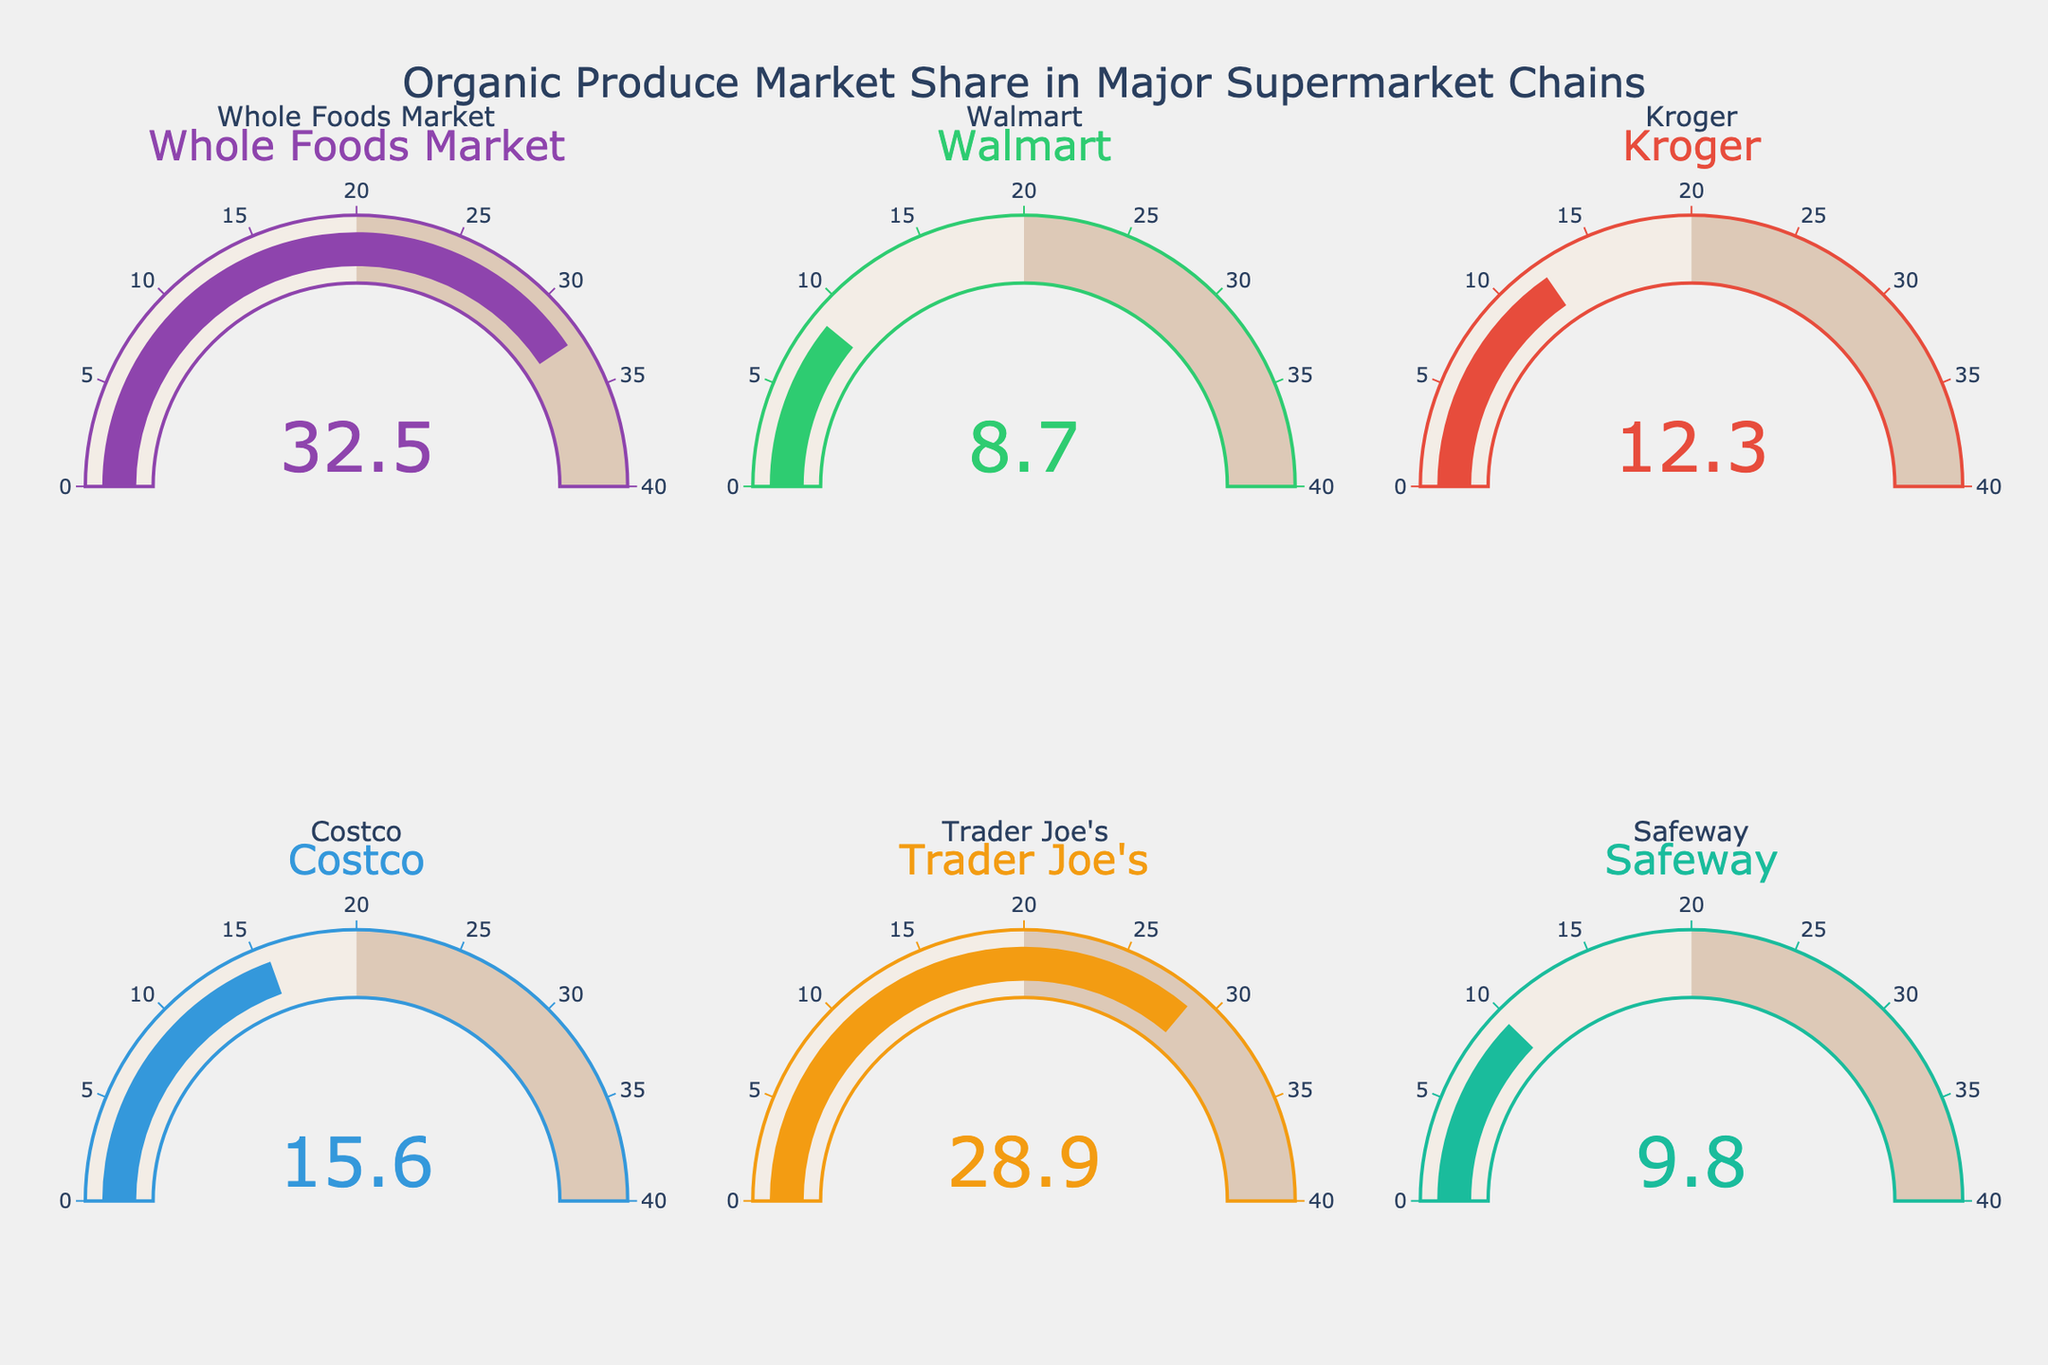what is the market share of organic produce for Whole Foods Market? The gauge chart for Whole Foods Market shows the number 32.5, indicating the market share percentage.
Answer: 32.5% which supermarket chain has the lowest market share for organic produce? By comparing the values in each gauge chart, Walmart has the lowest market share at 8.7.
Answer: Walmart what is the combined market share for organic produce between Trader Joe's and Kroger? Trader Joe's has a market share of 28.9% and Kroger has 12.3%. Adding these together, 28.9 + 12.3 = 41.2%.
Answer: 41.2% how much more organic produce market share does Whole Foods Market have compared to Safeway? Whole Foods Market has 32.5% market share, and Safeway has 9.8%. The difference is 32.5 - 9.8 = 22.7%.
Answer: 22.7% which supermarket chain has a market share closest to 10%? Safeway has a market share of 9.8%, which is closest to 10%.
Answer: Safeway what is the average market share of organic produce for all the supermarket chains shown? The market shares are 32.5, 8.7, 12.3, 15.6, 28.9, and 9.8. Sum them to get 32.5 + 8.7 + 12.3 + 15.6 + 28.9 + 9.8 = 107.8. There are 6 chains, so the average is 107.8 / 6 ≈ 17.97%.
Answer: 17.97% which pair of supermarket chains have the closest market shares for organic produce? Comparing all pairs, Whole Foods Market (32.5%) and Trader Joe's (28.9%) have the closest market shares with a difference of 32.5 - 28.9 = 3.6%.
Answer: Whole Foods Market and Trader Joe's which two chains together make up more than half of the total market share? Adding the top two shares, Whole Foods Market (32.5%) and Trader Joe's (28.9%), gives 32.5 + 28.9 = 61.4%, which is more than half of the total (50%).
Answer: Whole Foods Market and Trader Joe's 